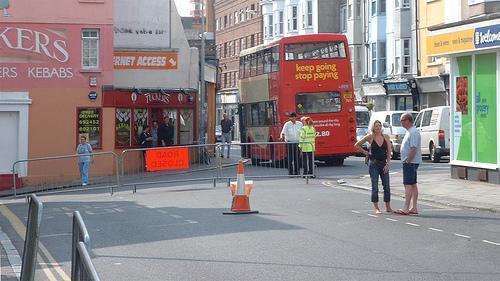Where are these 2 people standing?
Answer the question by selecting the correct answer among the 4 following choices.
Options: Grass, street, trail, beach. Street. 